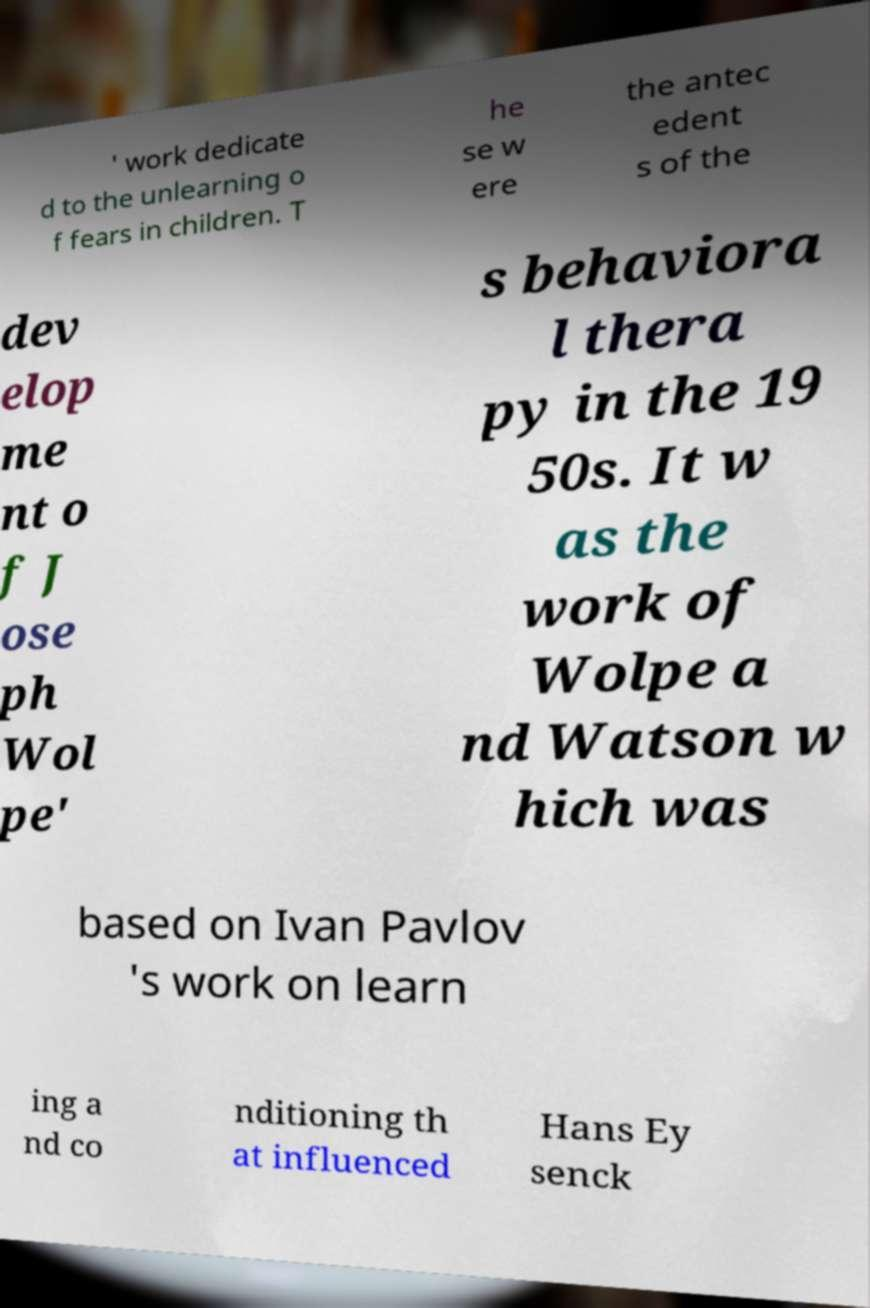Can you accurately transcribe the text from the provided image for me? ' work dedicate d to the unlearning o f fears in children. T he se w ere the antec edent s of the dev elop me nt o f J ose ph Wol pe' s behaviora l thera py in the 19 50s. It w as the work of Wolpe a nd Watson w hich was based on Ivan Pavlov 's work on learn ing a nd co nditioning th at influenced Hans Ey senck 